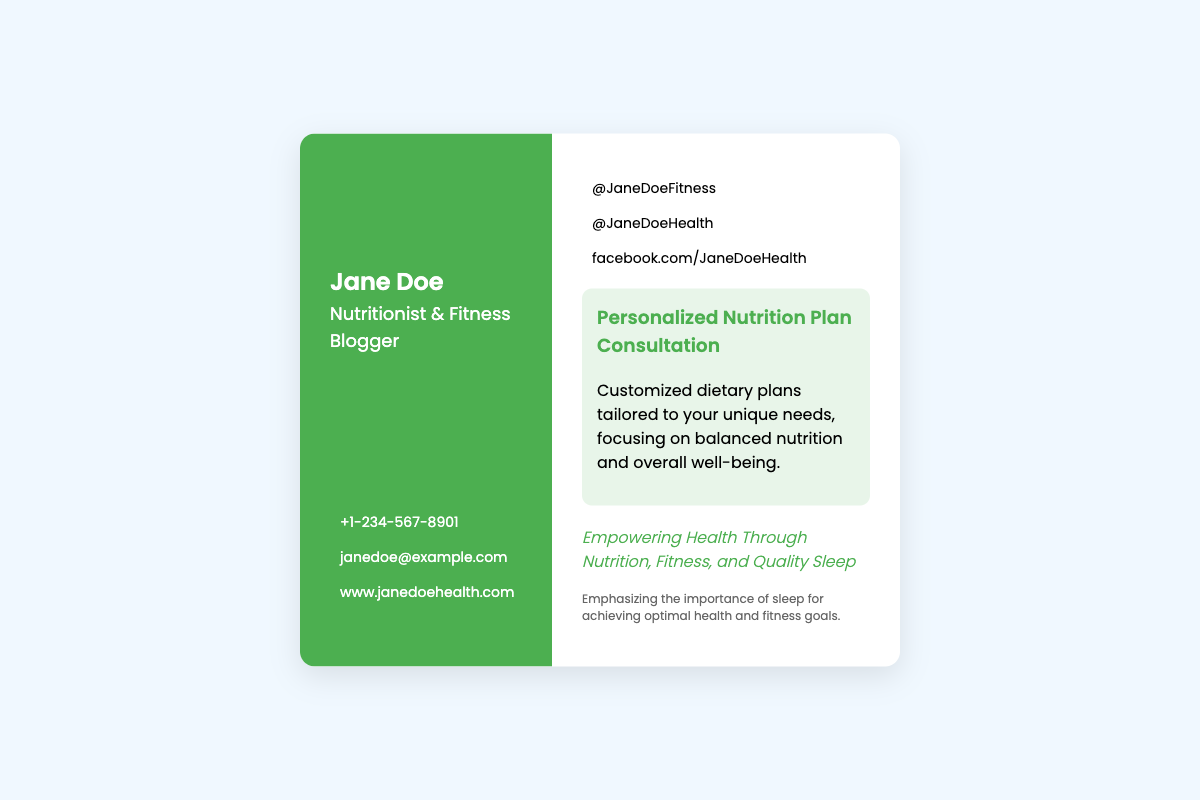What is the name of the nutritionist? The name of the nutritionist is prominently displayed at the top of the business card.
Answer: Jane Doe What services does Jane Doe offer? The business card outlines the specific services offered, which are highlighted in the services section.
Answer: Personalized Nutrition Plan Consultation What is Jane Doe's phone number? The business card contains contact information, including a phone number listed under the contact information section.
Answer: +1-234-567-8901 What is the focus of the Personalized Nutrition Plan Consultation? The description under the service provides insight into the focus of the consultation service.
Answer: Balanced nutrition and overall well-being How does Jane Doe emphasize health through her work? The tagline section indicates the overall philosophy and approach taken by Jane Doe as a nutritionist and fitness blogger.
Answer: Empowering Health Through Nutrition, Fitness, and Quality Sleep What social media platform is Jane Doe on? The business card includes a section with social media handles related to Jane Doe's professional accounts.
Answer: Instagram What color scheme is used for the left side of the card? The design elements of the business card can be described by identifying the specific colors used for each section.
Answer: Green What does the additional notes section emphasize? This section of the business card provides extra information that complements the main offerings.
Answer: Importance of sleep for achieving optimal health and fitness goals 